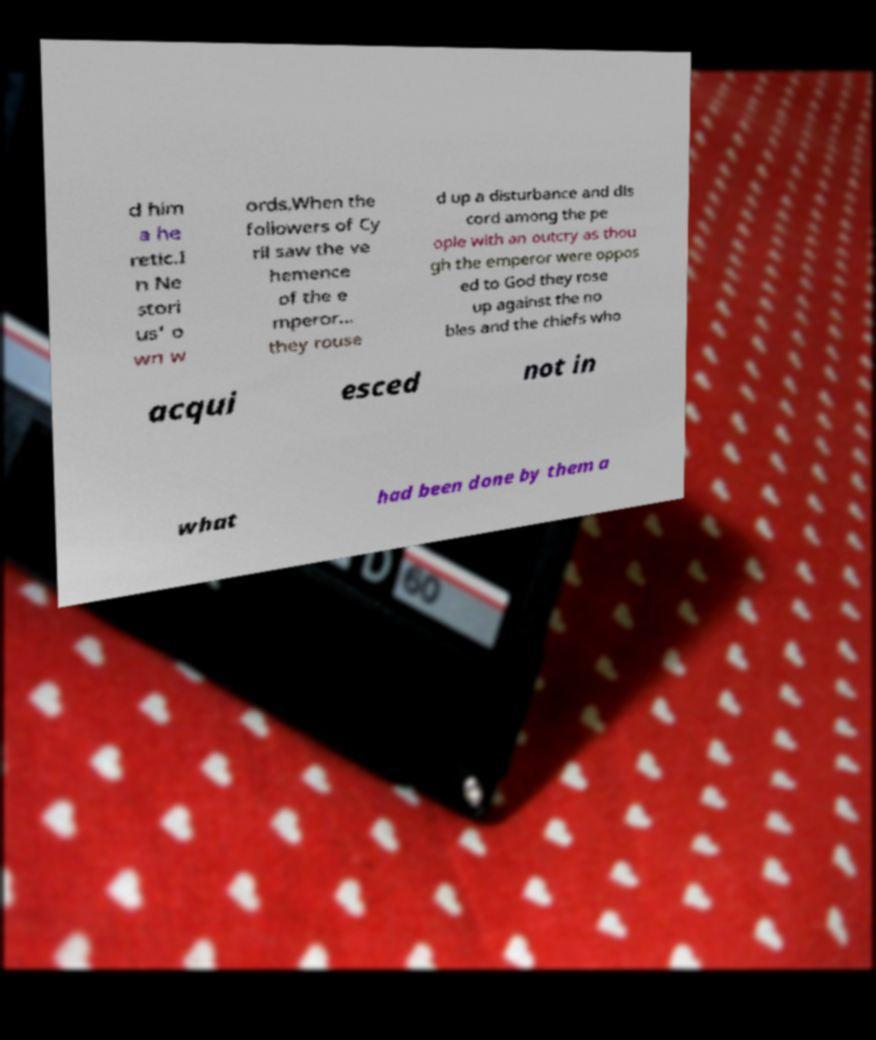For documentation purposes, I need the text within this image transcribed. Could you provide that? d him a he retic.I n Ne stori us' o wn w ords,When the followers of Cy ril saw the ve hemence of the e mperor... they rouse d up a disturbance and dis cord among the pe ople with an outcry as thou gh the emperor were oppos ed to God they rose up against the no bles and the chiefs who acqui esced not in what had been done by them a 